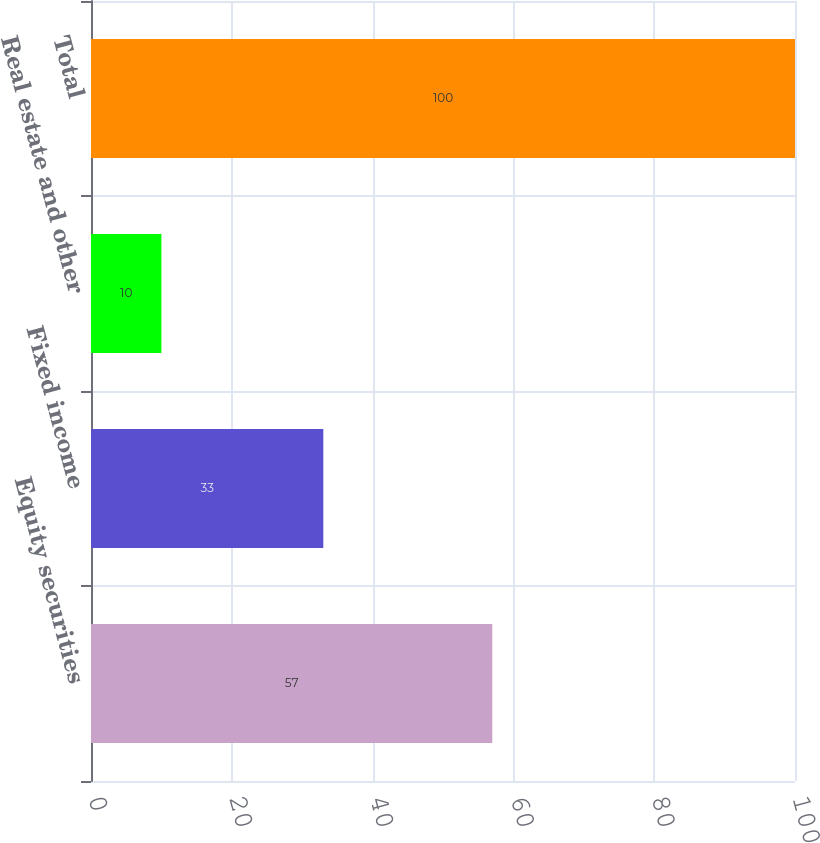Convert chart. <chart><loc_0><loc_0><loc_500><loc_500><bar_chart><fcel>Equity securities<fcel>Fixed income<fcel>Real estate and other<fcel>Total<nl><fcel>57<fcel>33<fcel>10<fcel>100<nl></chart> 